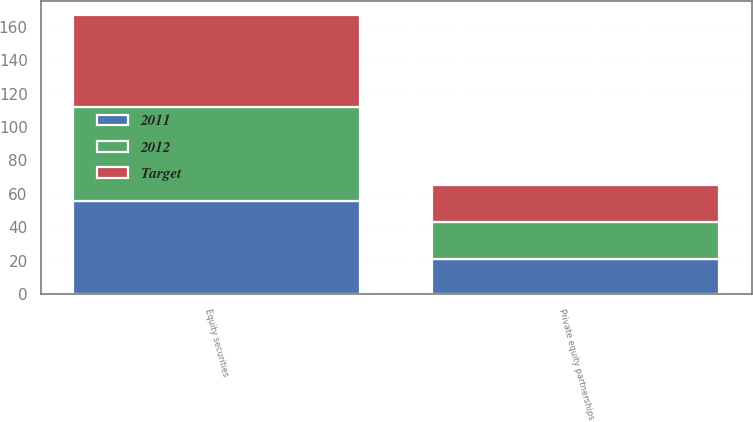Convert chart. <chart><loc_0><loc_0><loc_500><loc_500><stacked_bar_chart><ecel><fcel>Equity securities<fcel>Private equity partnerships<nl><fcel>2012<fcel>56<fcel>22<nl><fcel>2011<fcel>56<fcel>21<nl><fcel>Target<fcel>55<fcel>22<nl></chart> 